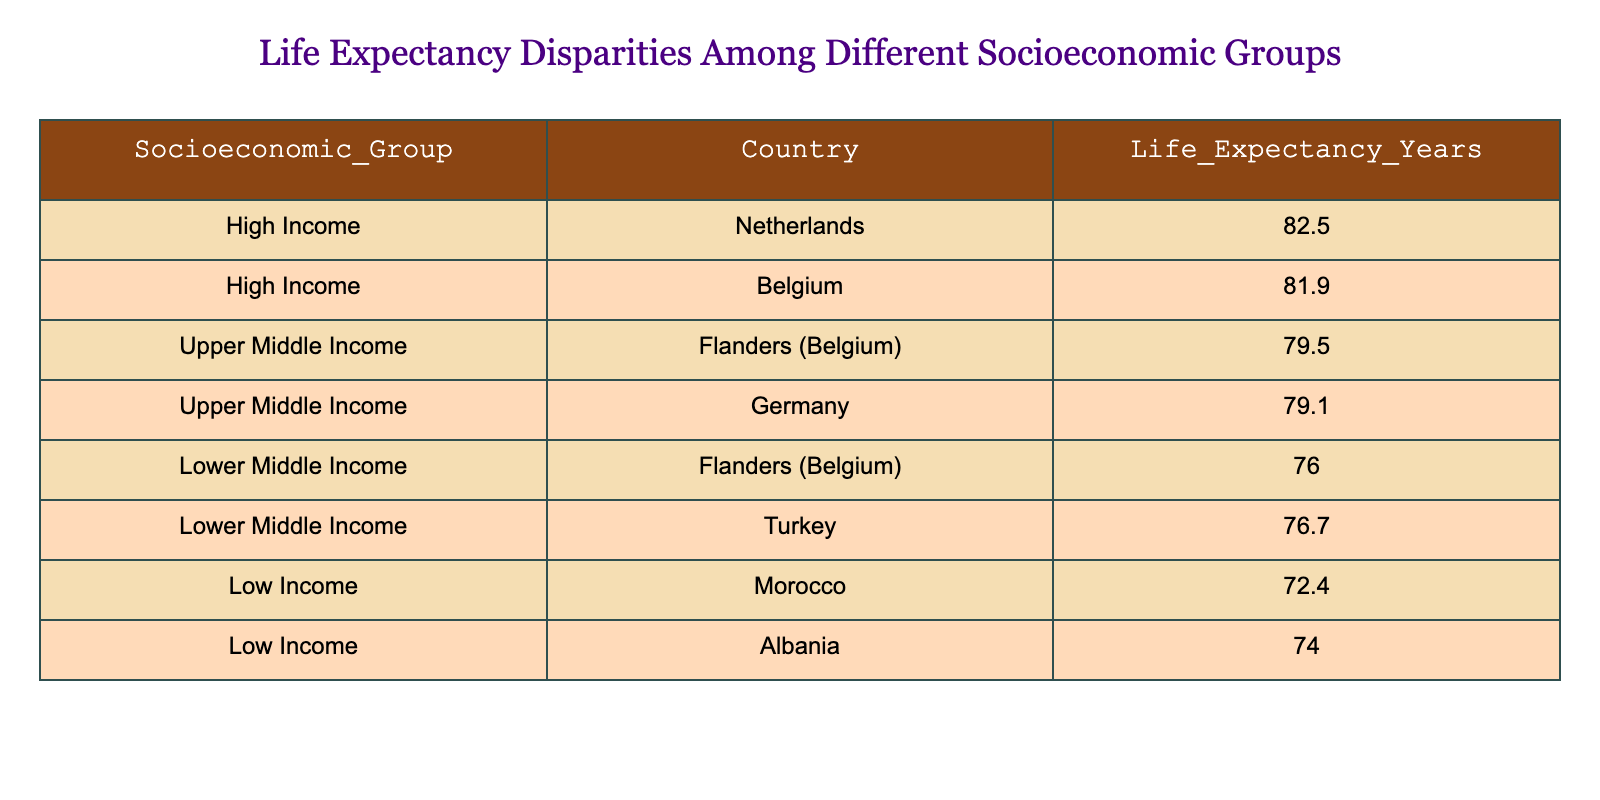What is the life expectancy for High Income countries in this table? There are two High Income countries listed: the Netherlands with a life expectancy of 82.5 years and Belgium with 81.9 years. The life expectancy for High Income countries is the average of these two values, which is (82.5 + 81.9) / 2 = 82.2 years.
Answer: 82.2 What is the difference in life expectancy between Lower Middle Income Flanders (Belgium) and Lower Middle Income Turkey? The life expectancy for Lower Middle Income Flanders (Belgium) is 76.0 years and for Turkey, it is 76.7 years. To find the difference, we subtract the Flanders value from the Turkey value: 76.7 - 76.0 = 0.7 years.
Answer: 0.7 Is the life expectancy of Upper Middle Income Flanders (Belgium) higher than that of Lower Middle Income Flanders (Belgium)? The life expectancy of Upper Middle Income Flanders (Belgium) is 79.5 years, while the Lower Middle Income Flanders (Belgium) has a life expectancy of 76.0 years. Since 79.5 is greater than 76.0, the statement is true.
Answer: Yes Which socioeconomic group has the lowest life expectancy in the table? The Low Income group has two entries, Morocco at 72.4 years and Albania at 74.0 years. The lower of the two is Morocco at 72.4 years, making it the group with the lowest life expectancy.
Answer: Low Income (Morocco) 72.4 What is the average life expectancy of all the countries listed in the table? To find the average, we first sum all life expectancies: (82.5 + 81.9 + 79.5 + 79.1 + 76.0 + 76.7 + 72.4 + 74.0) = 610.3. There are 8 countries listed, so we divide the total sum by 8: 610.3 / 8 = 76.29.
Answer: 76.29 